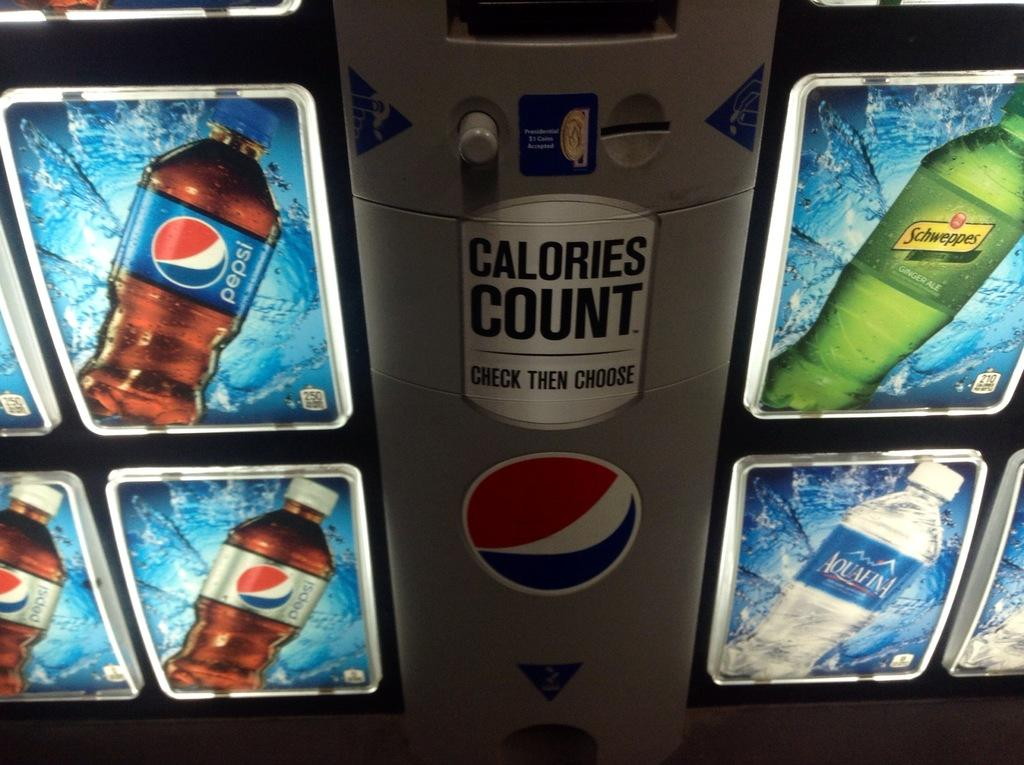<image>
Give a short and clear explanation of the subsequent image. A vending machine with plastic bottled Pepsi among other drinks. 